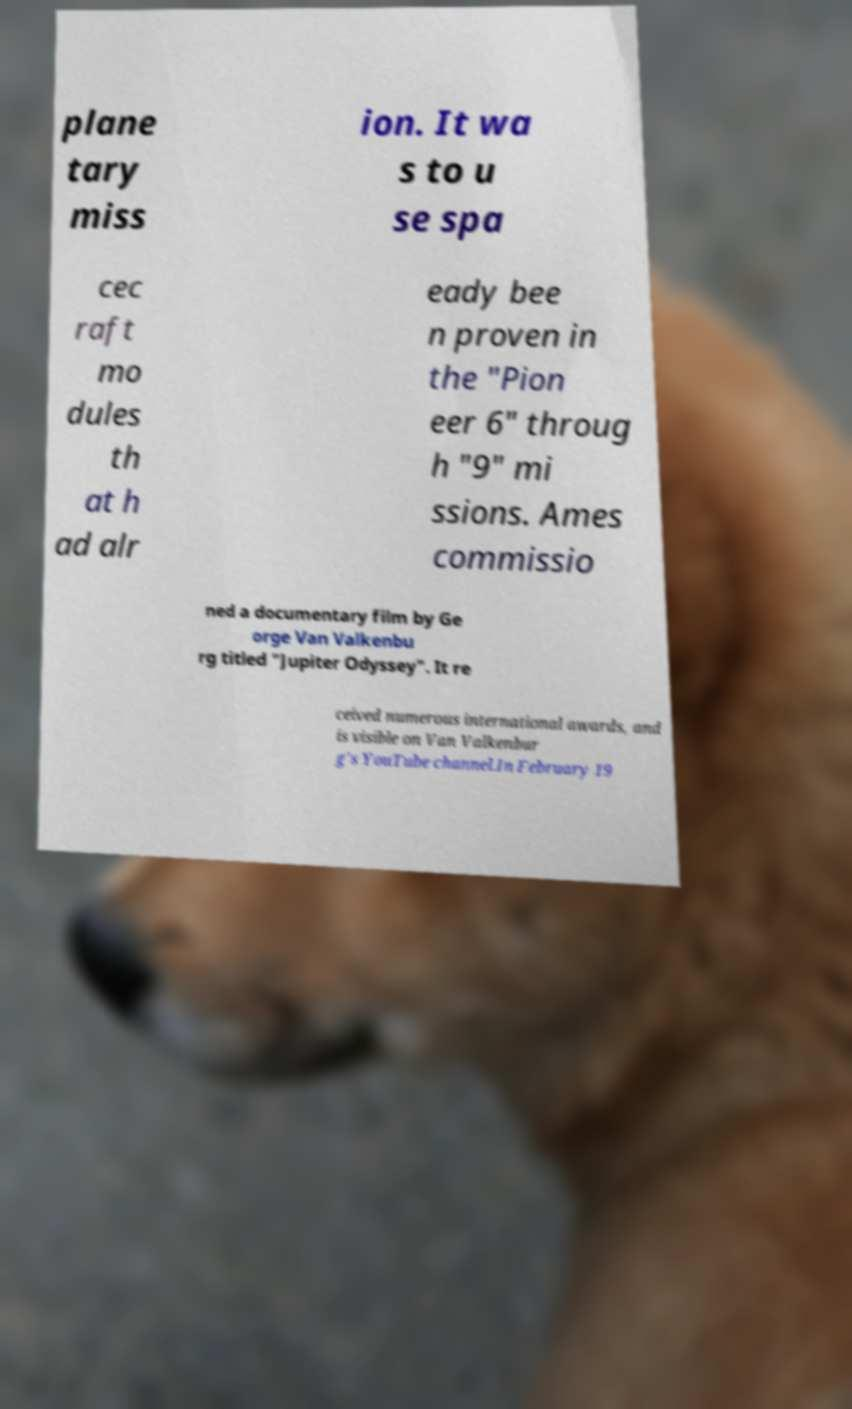I need the written content from this picture converted into text. Can you do that? plane tary miss ion. It wa s to u se spa cec raft mo dules th at h ad alr eady bee n proven in the "Pion eer 6" throug h "9" mi ssions. Ames commissio ned a documentary film by Ge orge Van Valkenbu rg titled "Jupiter Odyssey". It re ceived numerous international awards, and is visible on Van Valkenbur g's YouTube channel.In February 19 